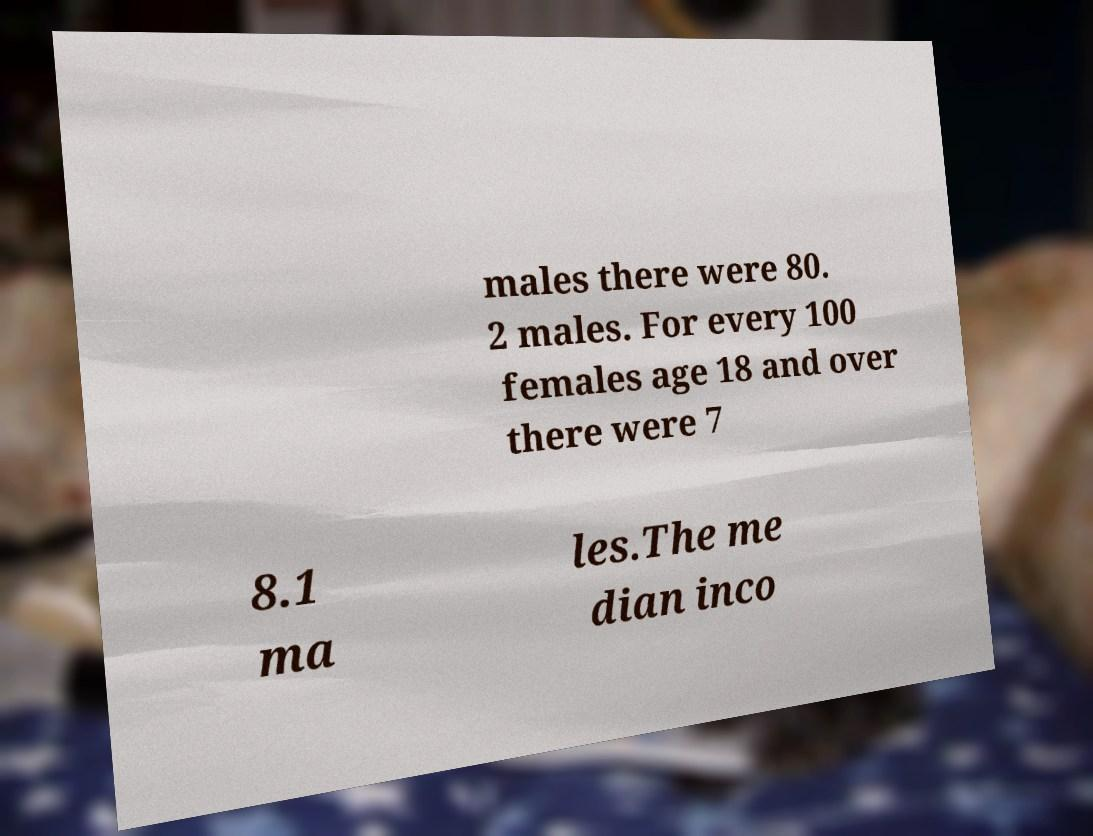Can you accurately transcribe the text from the provided image for me? males there were 80. 2 males. For every 100 females age 18 and over there were 7 8.1 ma les.The me dian inco 